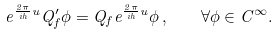<formula> <loc_0><loc_0><loc_500><loc_500>e ^ { \frac { 2 \pi } { i h } u } Q ^ { \prime } _ { f } \phi = Q _ { f } e ^ { \frac { 2 \pi } { i h } u } \phi \, , \quad \forall \phi \in C ^ { \infty } .</formula> 